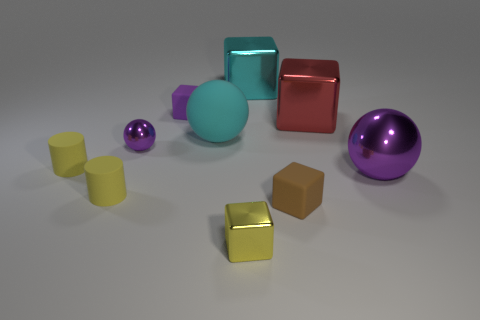Subtract all cyan blocks. How many blocks are left? 4 Subtract all cyan blocks. How many blocks are left? 4 Subtract all blue cubes. Subtract all green balls. How many cubes are left? 5 Subtract all cylinders. How many objects are left? 8 Add 9 large brown matte objects. How many large brown matte objects exist? 9 Subtract 1 cyan cubes. How many objects are left? 9 Subtract all tiny cyan cubes. Subtract all yellow rubber things. How many objects are left? 8 Add 4 big rubber spheres. How many big rubber spheres are left? 5 